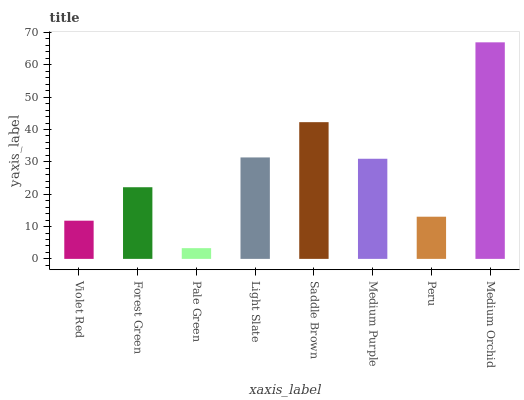Is Pale Green the minimum?
Answer yes or no. Yes. Is Medium Orchid the maximum?
Answer yes or no. Yes. Is Forest Green the minimum?
Answer yes or no. No. Is Forest Green the maximum?
Answer yes or no. No. Is Forest Green greater than Violet Red?
Answer yes or no. Yes. Is Violet Red less than Forest Green?
Answer yes or no. Yes. Is Violet Red greater than Forest Green?
Answer yes or no. No. Is Forest Green less than Violet Red?
Answer yes or no. No. Is Medium Purple the high median?
Answer yes or no. Yes. Is Forest Green the low median?
Answer yes or no. Yes. Is Medium Orchid the high median?
Answer yes or no. No. Is Peru the low median?
Answer yes or no. No. 